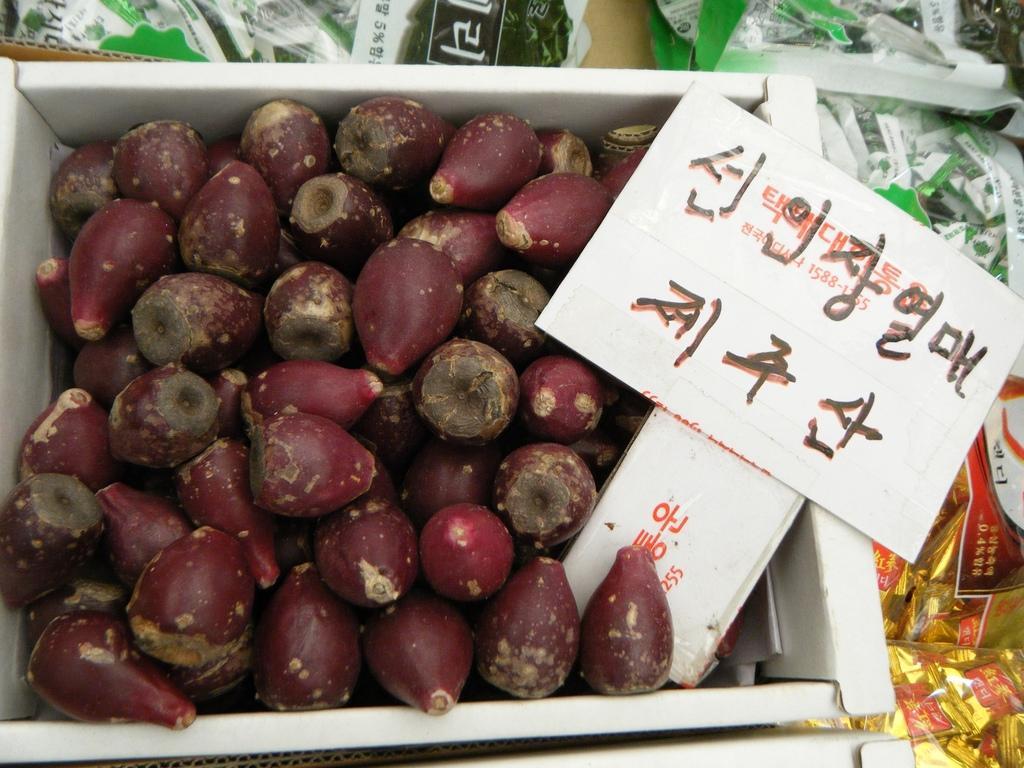In one or two sentences, can you explain what this image depicts? In this picture we can see some vegetables which are in box and we can see name board and there is some text on it. 